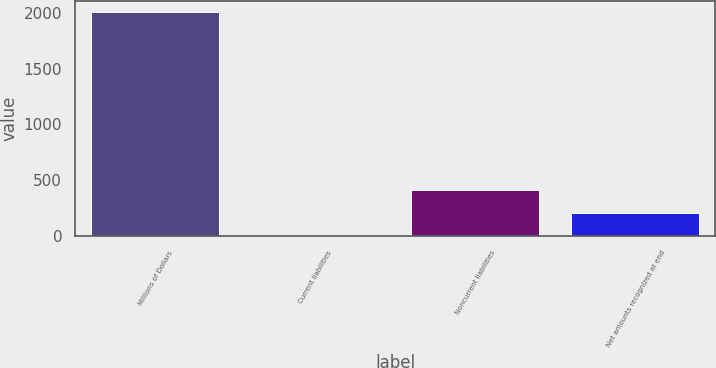Convert chart to OTSL. <chart><loc_0><loc_0><loc_500><loc_500><bar_chart><fcel>Millions of Dollars<fcel>Current liabilities<fcel>Noncurrent liabilities<fcel>Net amounts recognized at end<nl><fcel>2007<fcel>11<fcel>410.2<fcel>210.6<nl></chart> 